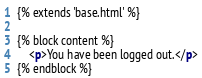<code> <loc_0><loc_0><loc_500><loc_500><_HTML_>{% extends 'base.html' %}

{% block content %}
    <p>You have been logged out.</p>
{% endblock %}</code> 